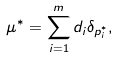<formula> <loc_0><loc_0><loc_500><loc_500>\mu ^ { * } = \sum _ { i = 1 } ^ { m } d _ { i } \delta _ { p _ { i } ^ { * } } ,</formula> 